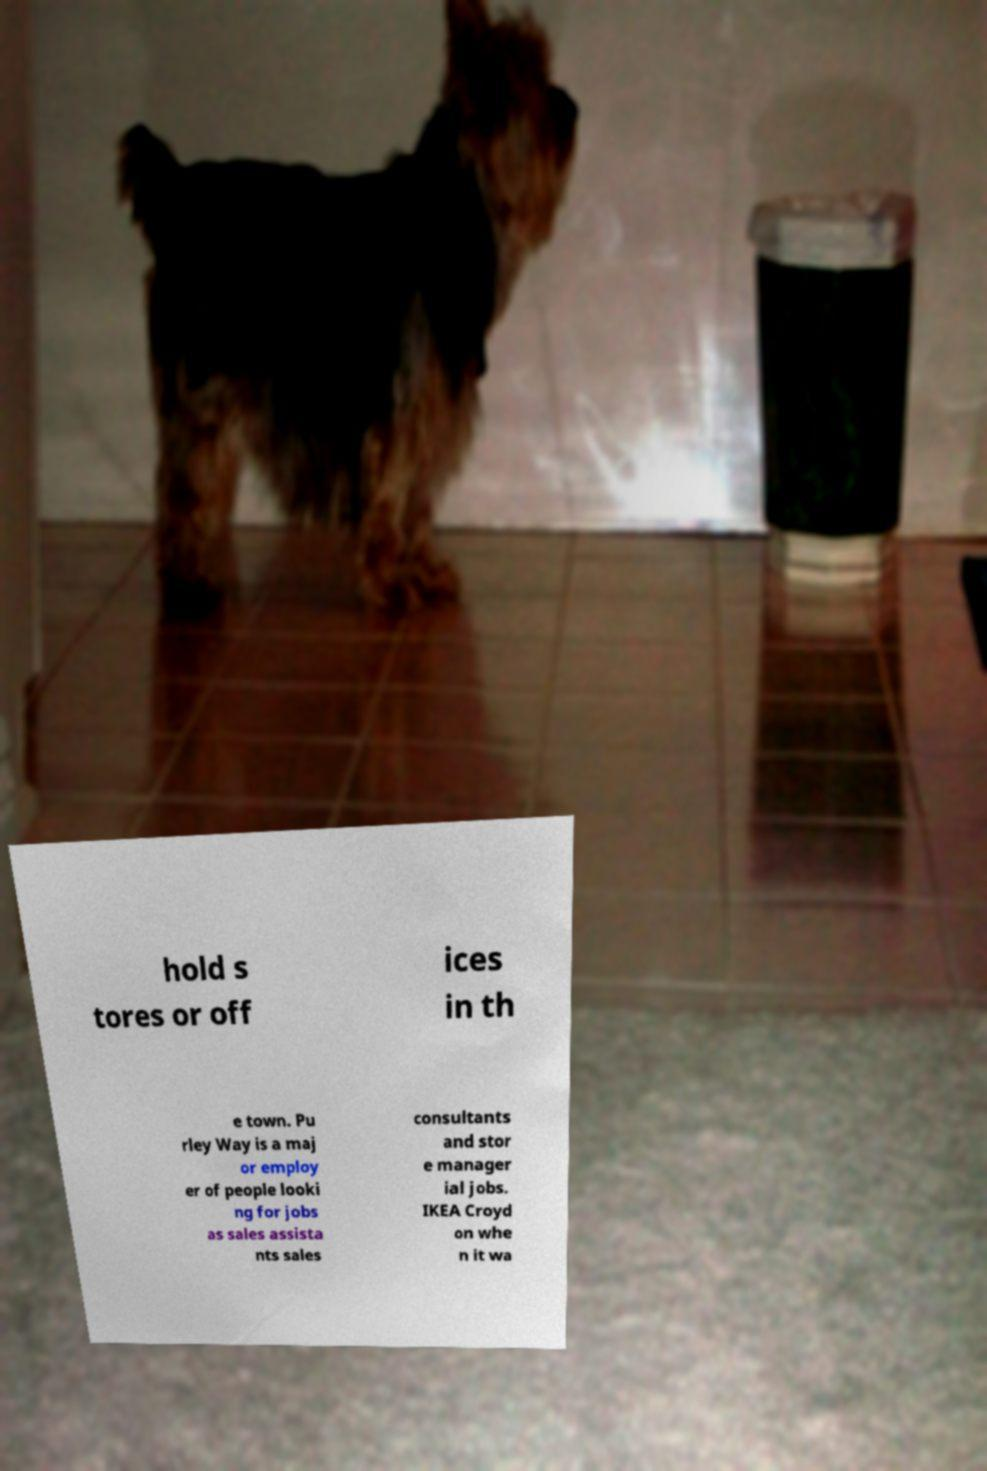For documentation purposes, I need the text within this image transcribed. Could you provide that? hold s tores or off ices in th e town. Pu rley Way is a maj or employ er of people looki ng for jobs as sales assista nts sales consultants and stor e manager ial jobs. IKEA Croyd on whe n it wa 